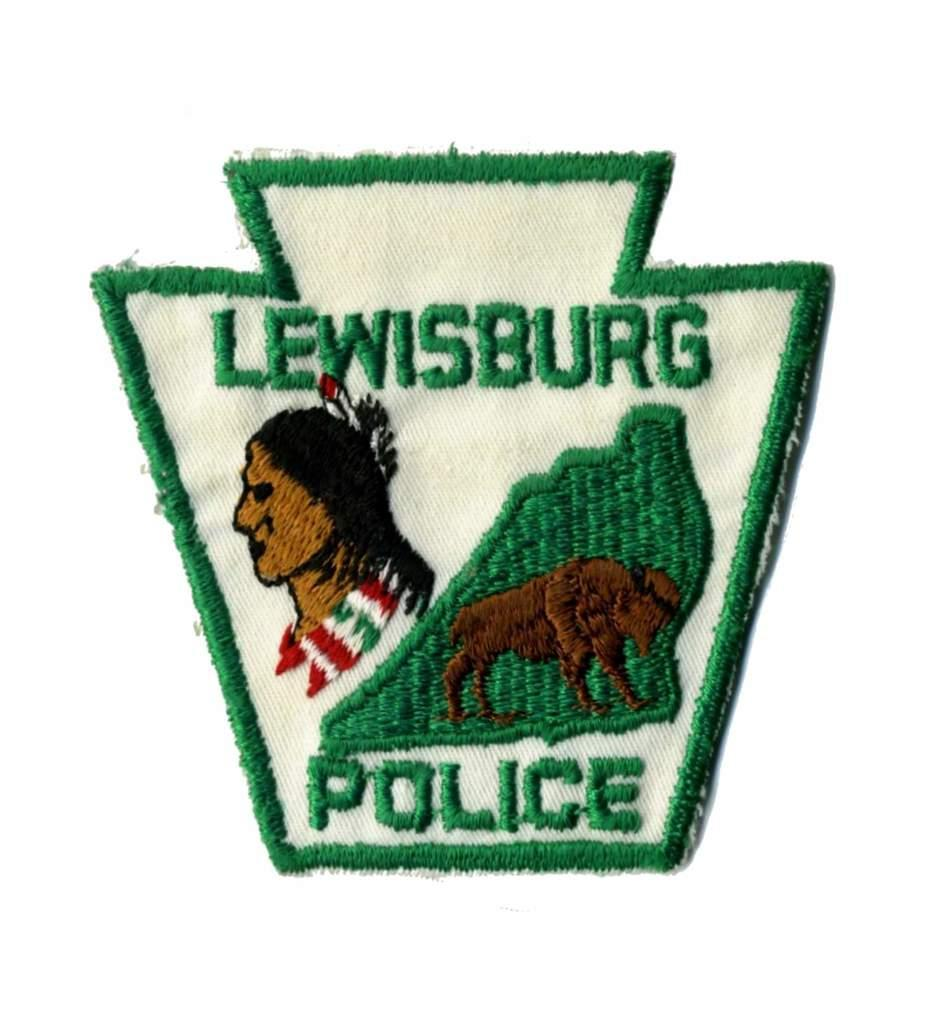What is the main feature of the image? The main feature of the image is a logo. Can you describe the elements of the logo? The logo contains images and text. How is the logo created? The logo is embroidery work on cloth. What type of paint is used to create the logo in the image? There is no paint used in the image; the logo is created through embroidery work on cloth. 